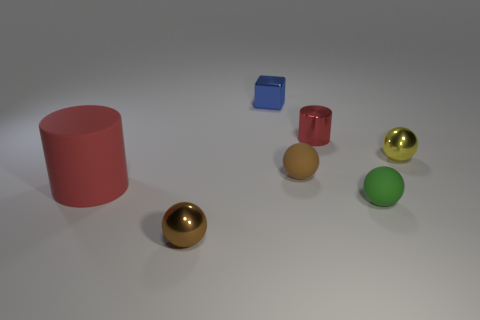Subtract all red cylinders. How many were subtracted if there are1red cylinders left? 1 Add 1 small matte cylinders. How many objects exist? 8 Subtract all green spheres. How many spheres are left? 3 Subtract all brown metal spheres. How many spheres are left? 3 Subtract 1 blue cubes. How many objects are left? 6 Subtract all balls. How many objects are left? 3 Subtract 1 blocks. How many blocks are left? 0 Subtract all yellow cylinders. Subtract all brown spheres. How many cylinders are left? 2 Subtract all cyan cylinders. How many red cubes are left? 0 Subtract all large yellow matte cubes. Subtract all tiny metal balls. How many objects are left? 5 